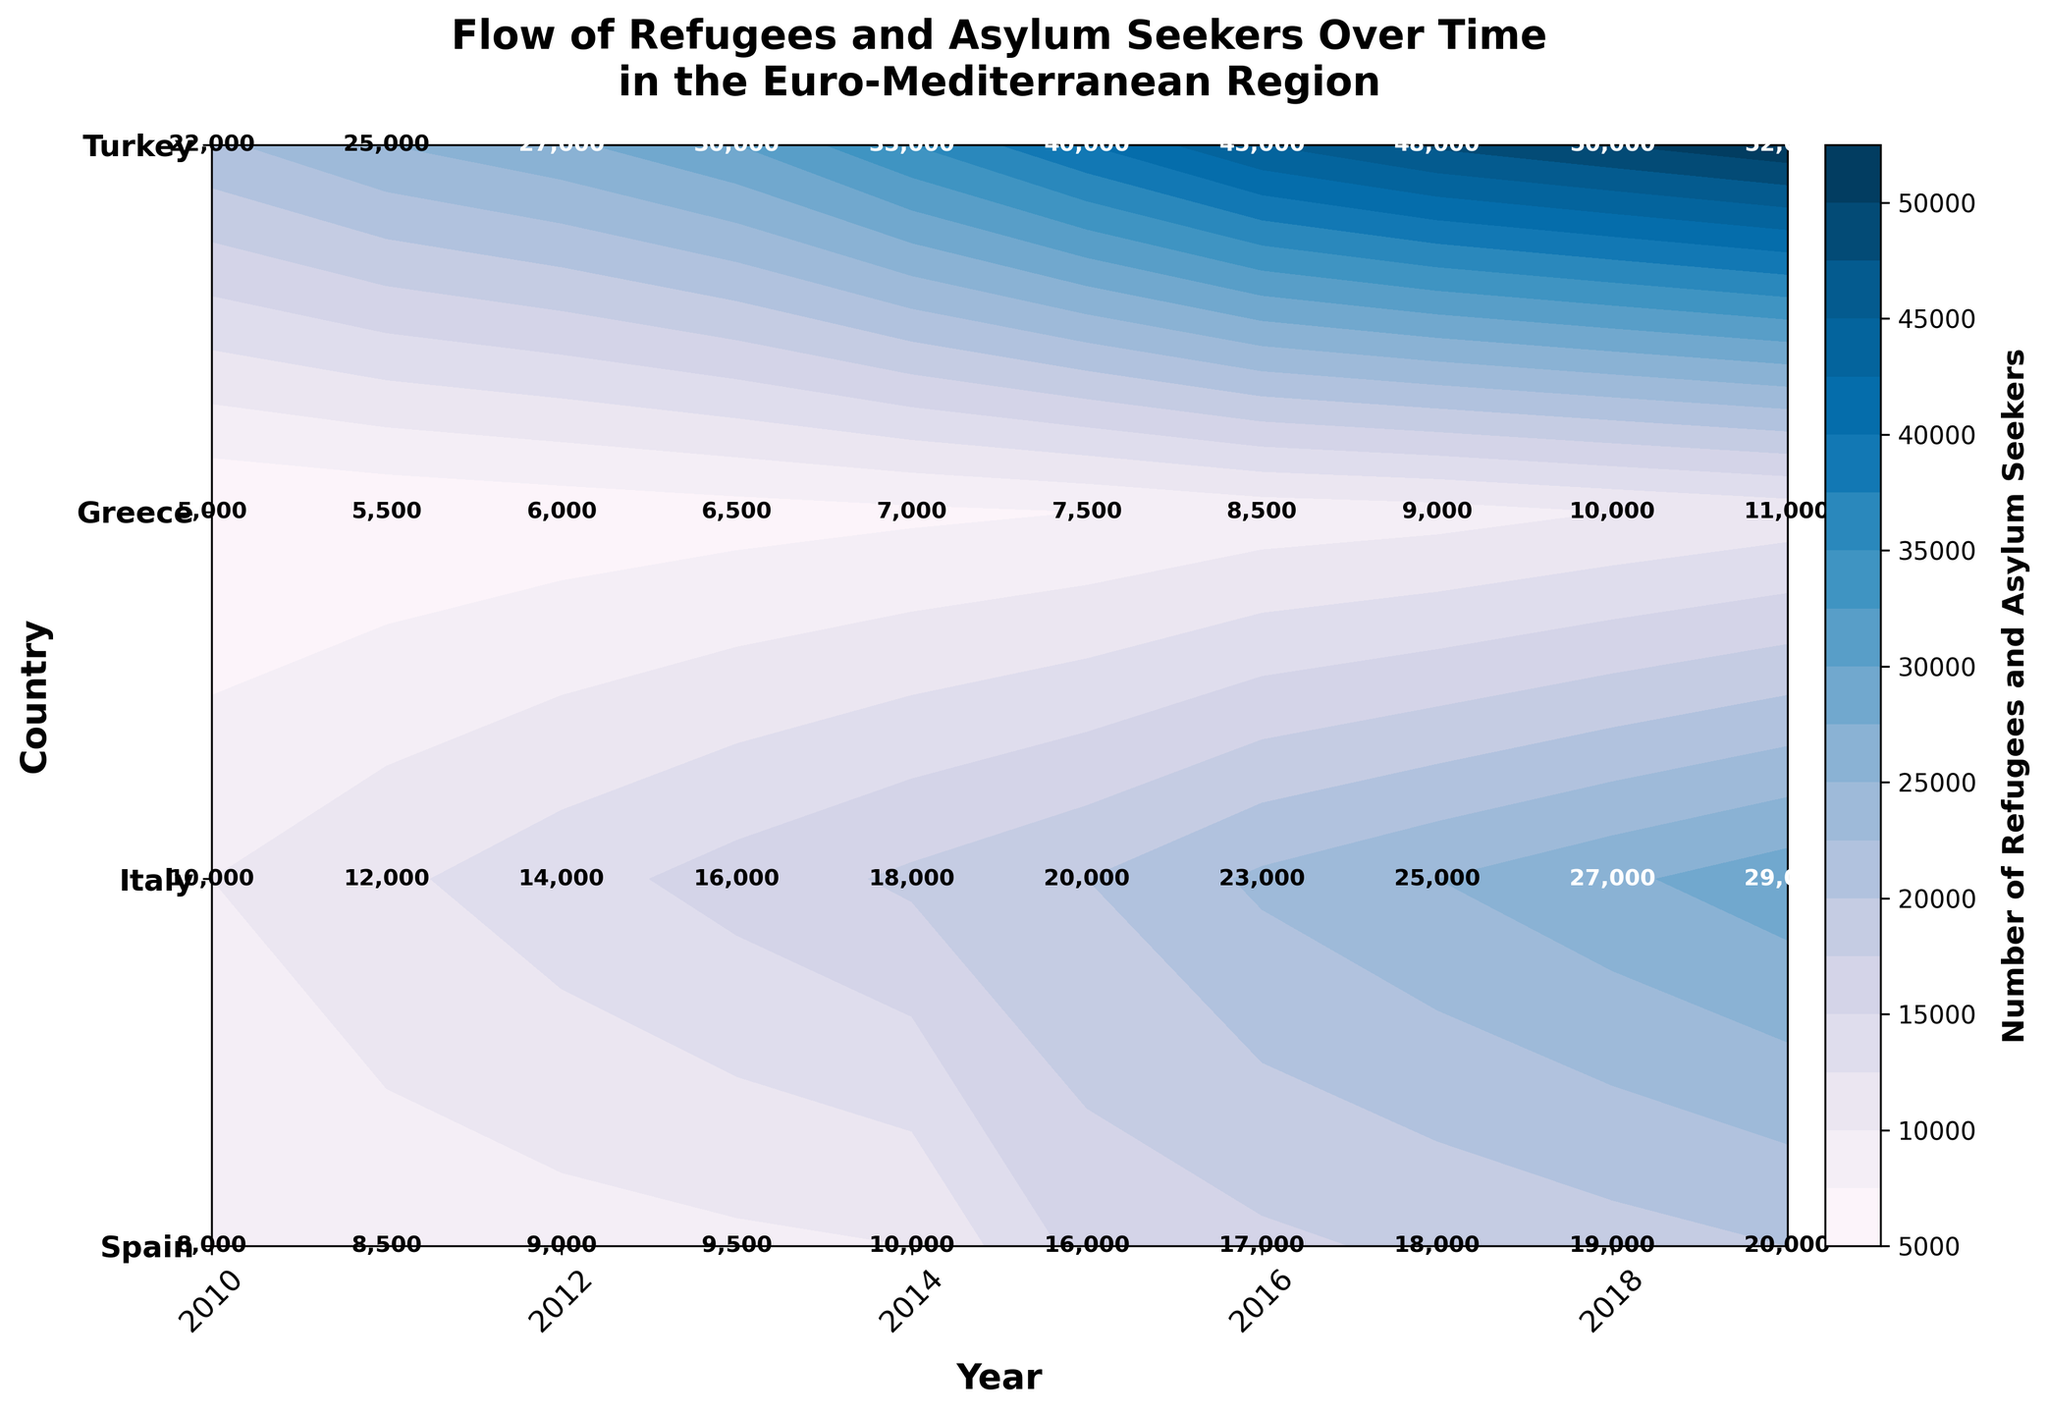What is the title of the plot? The title is generally found at the top of the plot. In this case, it is 'Flow of Refugees and Asylum Seekers Over Time in the Euro-Mediterranean Region'
Answer: Flow of Refugees and Asylum Seekers Over Time in the Euro-Mediterranean Region What does the color bar represent in the figure? The color bar, usually found on the side of the plot, indicates the numerical range the different colors represent. Here, it shows the number of Refugees and Asylum Seekers
Answer: Number of Refugees and Asylum Seekers Which country had the most significant number of refugees and asylum seekers in 2019? To answer this, we need to look at the 2019 column and identify the country associated with the darkest shade, which indicates the highest value. Turkey shows the darkest color and the value 52,000
Answer: Turkey Which years are labeled on the x-axis? The x-axis represents years and is labeled at every other year. The labels are found at the bottom of the plot and show years like 2010, 2012, 2014, 2016, 2018
Answer: 2010, 2012, 2014, 2016, 2018 What country shows a steady increase in the number of refugees and asylum seekers from 2010 to 2019? By observing the color gradient changes year by year for each country, Turkey shows a steady increase as its values increase continuously from 22,000 (2010) to 52,000 (2019)
Answer: Turkey Compare the number of refugees and asylum seekers in Greece and Italy in 2015. Which country had more? For comparison, we find the values for Greece and Italy in 2015 on the y-axis. Greece has 16,000 and Italy has 20,000. Italy had more.
Answer: Italy How does the number of refugees and asylum seekers in Spain change from 2010 to 2019? To answer this, track Spain’s values from 2010 to 2019 on the plot. The values rise steadily from 5,000 in 2010 to 11,000 in 2019, indicating an upward trend
Answer: Increases Between 2012 and 2014, which country shows the highest increase in the number of refugees and asylum seekers? Calculate the difference between values for 2012 and 2014 for each country. Turkey shows the highest increase, from 27,000 in 2012 to 35,000 in 2014, an increase of 8,000
Answer: Turkey What is the difference in the number of refugees and asylum seekers between Italy and Greece in 2018? Look at 2018 values for Italy (27,000) and Greece (19,000), then subtract Greece's value from Italy's value, resulting in 8,000
Answer: 8,000 